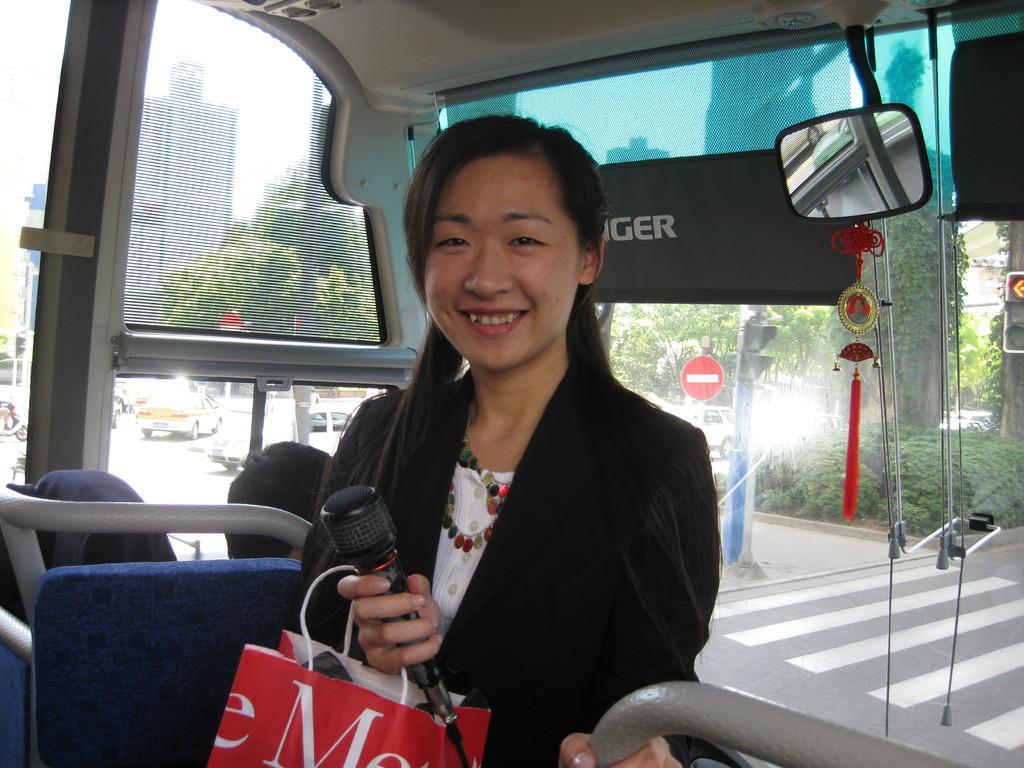Describe this image in one or two sentences. In the image we can see there is a woman standing in the bus and she is holding a cover and mic in her hand. Behind there are cars parked on the road and there are buildings. 